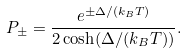Convert formula to latex. <formula><loc_0><loc_0><loc_500><loc_500>P _ { \pm } = \frac { e ^ { \pm \Delta / ( k _ { B } T ) } } { 2 \cosh ( \Delta / ( k _ { B } T ) ) } .</formula> 